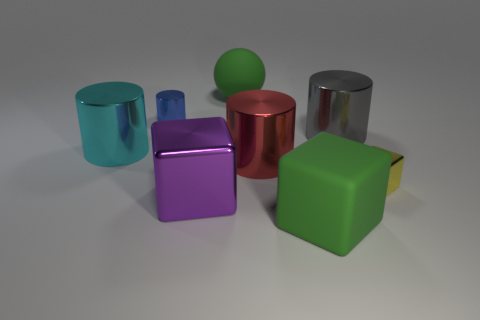The block that is the same size as the blue shiny cylinder is what color?
Make the answer very short. Yellow. What size is the green matte object in front of the matte object that is behind the red thing?
Your answer should be compact. Large. What size is the matte object that is the same color as the large rubber block?
Ensure brevity in your answer.  Large. What number of other objects are the same size as the green cube?
Provide a succinct answer. 5. How many small purple shiny spheres are there?
Ensure brevity in your answer.  0. Does the blue metallic cylinder have the same size as the yellow object?
Your response must be concise. Yes. How many other things are there of the same shape as the small blue metal object?
Make the answer very short. 3. There is a large cube on the right side of the large green rubber thing behind the large shiny block; what is its material?
Your answer should be compact. Rubber. Are there any gray cylinders left of the large cyan object?
Make the answer very short. No. There is a red shiny cylinder; is its size the same as the shiny cylinder that is left of the blue metal thing?
Provide a short and direct response. Yes. 